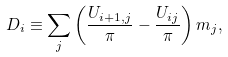Convert formula to latex. <formula><loc_0><loc_0><loc_500><loc_500>D _ { i } \equiv \sum _ { j } \left ( \frac { U _ { i + 1 , j } } { \pi } - \frac { U _ { i j } } { \pi } \right ) m _ { j } ,</formula> 